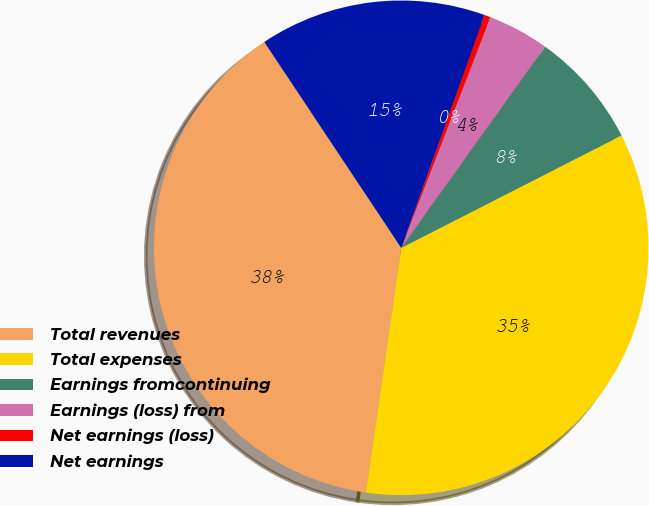Convert chart. <chart><loc_0><loc_0><loc_500><loc_500><pie_chart><fcel>Total revenues<fcel>Total expenses<fcel>Earnings fromcontinuing<fcel>Earnings (loss) from<fcel>Net earnings (loss)<fcel>Net earnings<nl><fcel>38.38%<fcel>34.79%<fcel>7.61%<fcel>4.01%<fcel>0.41%<fcel>14.8%<nl></chart> 